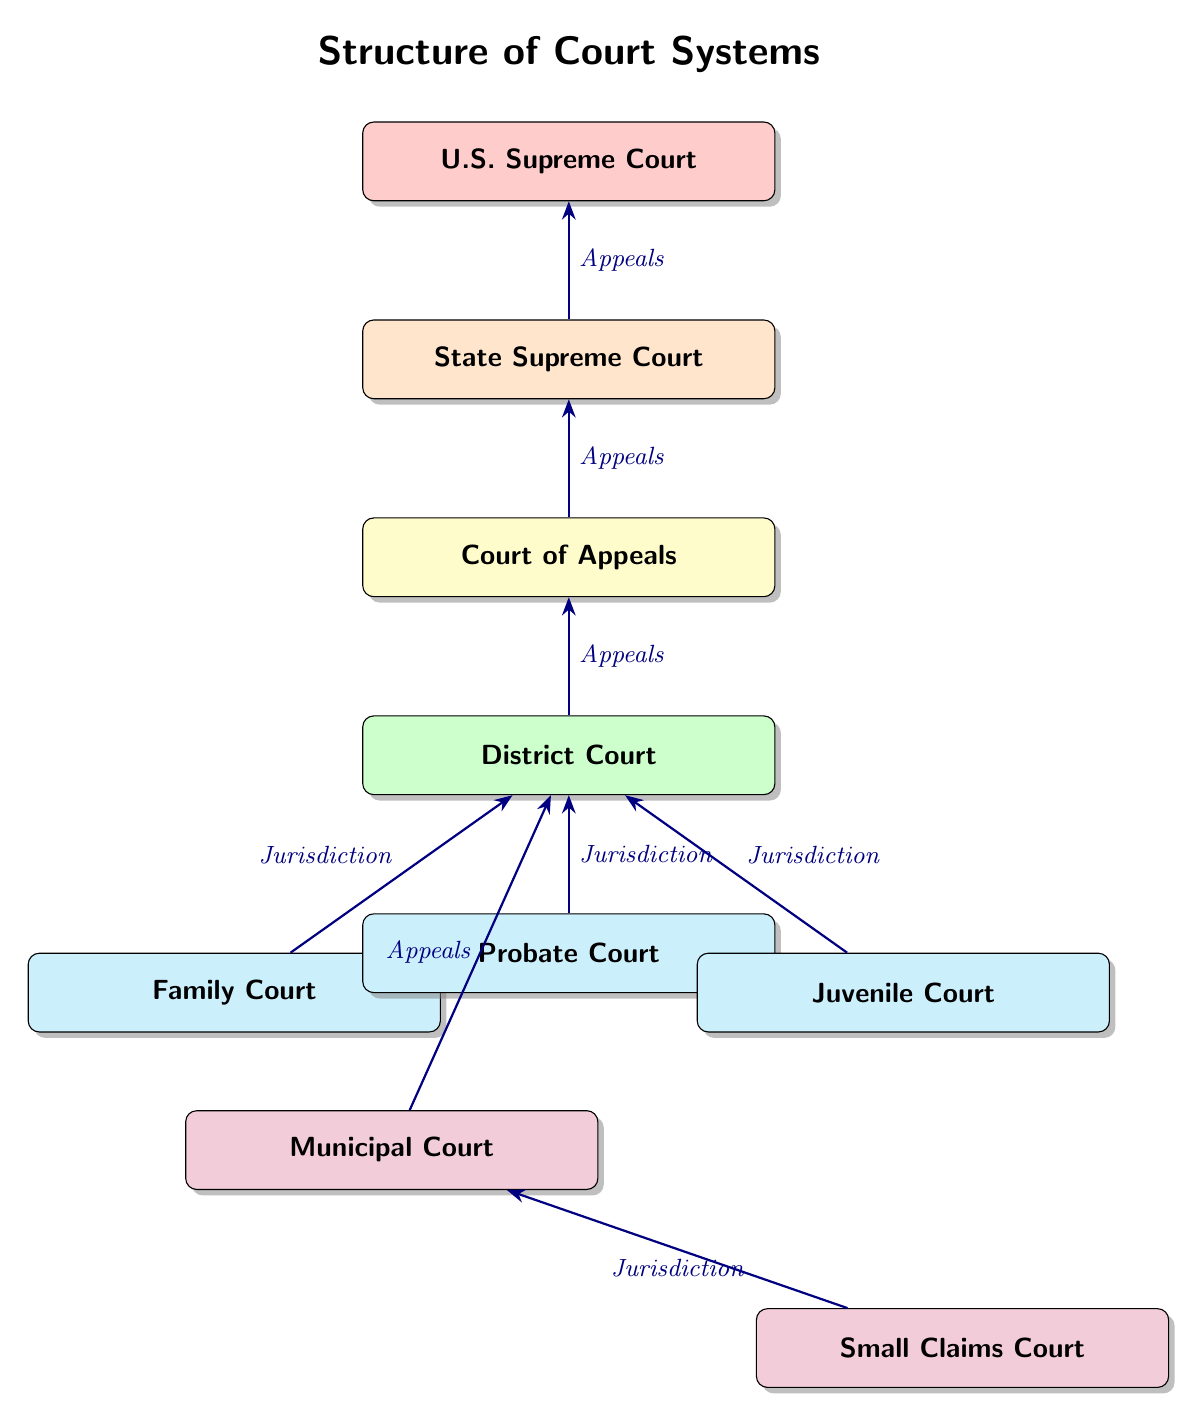What is the topmost court in the diagram? The topmost court in the hierarchy is the U.S. Supreme Court, which is positioned at the top of the diagram.
Answer: U.S. Supreme Court How many levels of court are shown in the diagram? The diagram displays four main levels of court: U.S. Supreme Court, State Supreme Court, Court of Appeals, and District Court.
Answer: 4 Which court has jurisdiction over Family Court cases? Family Court cases are under the jurisdiction of the District Court, as indicated by the direct connection (arrow) from Family Court to District Court.
Answer: District Court What type of court is directly below the Court of Appeals? Directly below the Court of Appeals in the hierarchy is the District Court, as shown by the arrow indicating an appeals relationship.
Answer: District Court Which two courts are connected to the District Court and indicate jurisdiction? The Family Court and Probate Court both have arrows pointing to the District Court, indicating that they are under its jurisdiction.
Answer: Family Court and Probate Court What type of court is directly connected to the Municipal Court? The Small Claims Court is directly connected to the Municipal Court, as shown by the arrow indicating jurisdiction between them.
Answer: Small Claims Court How does the relationship between the State Supreme Court and U.S. Supreme Court function? The State Supreme Court is connected to the U.S. Supreme Court through an arrow indicating an appeals relationship; cases can be appealed from the State Supreme Court to the U.S. Supreme Court.
Answer: Appeals Which court system is at the farthest left of the diagram? The Municipal Court is positioned at the farthest left of the diagram, as indicated by its placement relative to other courts.
Answer: Municipal Court 